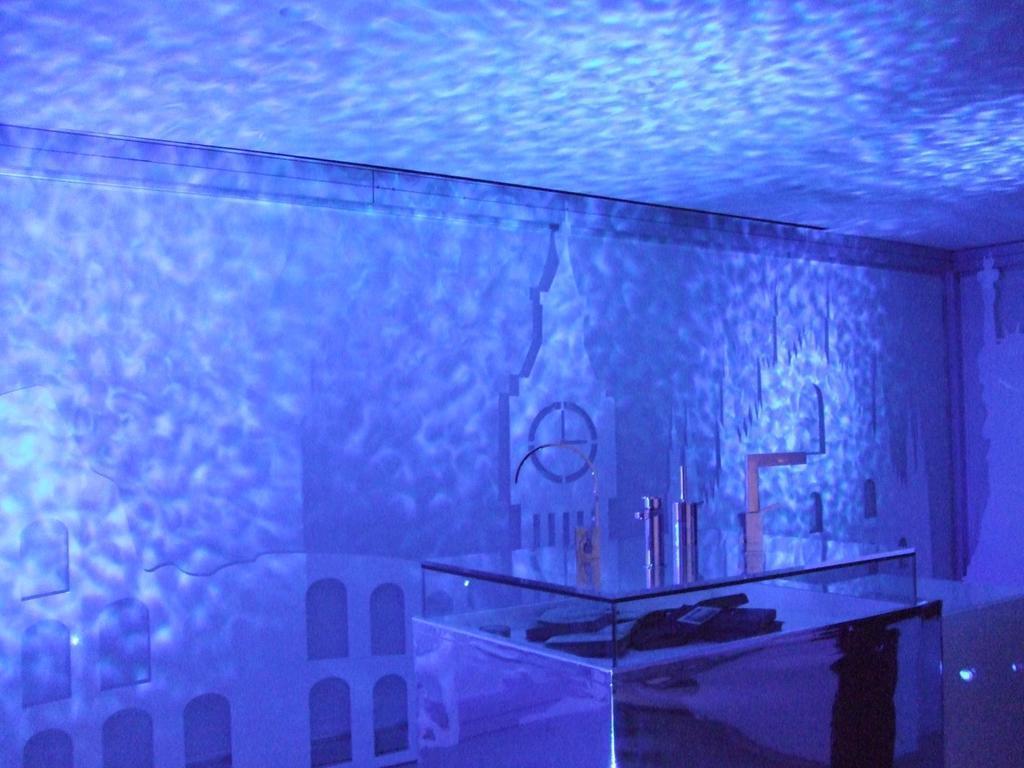In one or two sentences, can you explain what this image depicts? In this picture we can see a table in the middle, there is something present on the table, in the background we can see a clock and a wall, we can see reflection of lights on the wall. 